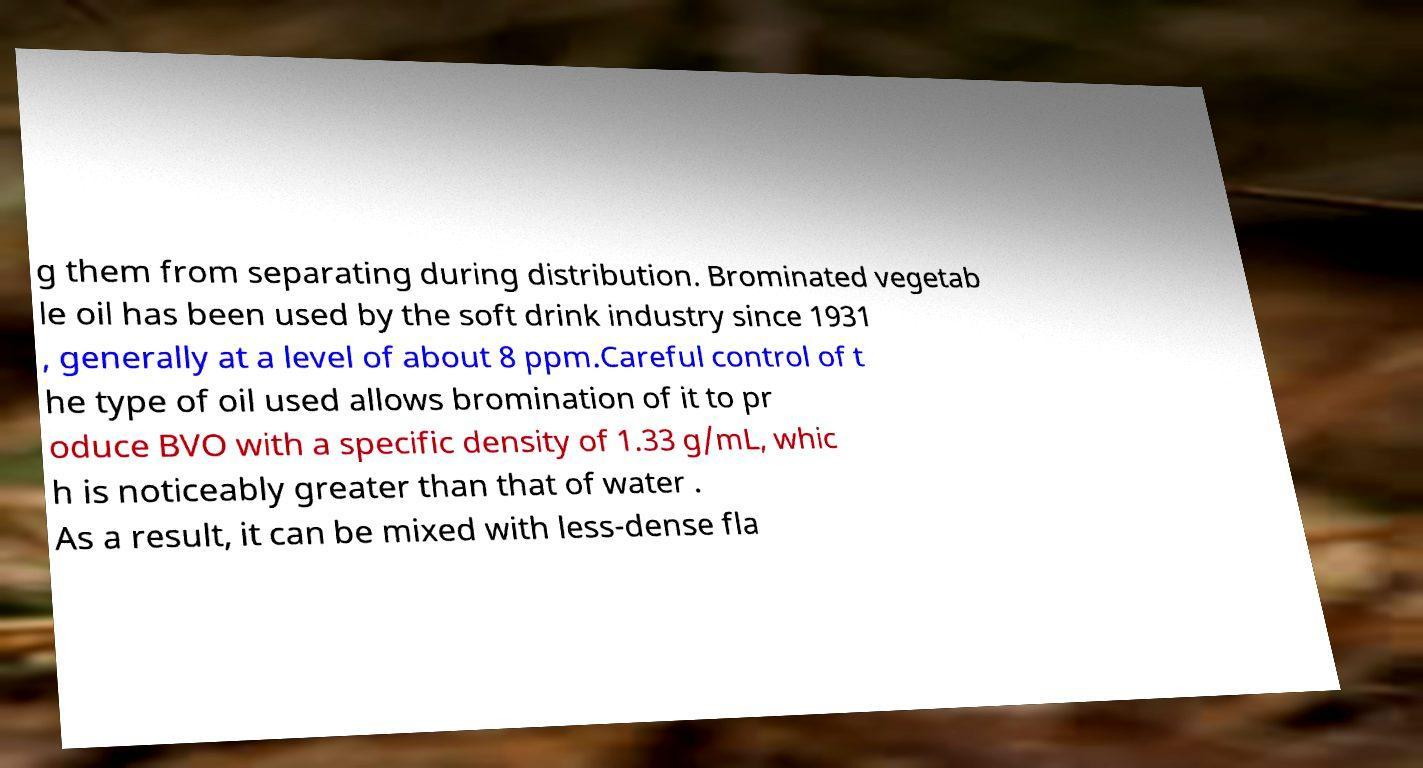Could you extract and type out the text from this image? g them from separating during distribution. Brominated vegetab le oil has been used by the soft drink industry since 1931 , generally at a level of about 8 ppm.Careful control of t he type of oil used allows bromination of it to pr oduce BVO with a specific density of 1.33 g/mL, whic h is noticeably greater than that of water . As a result, it can be mixed with less-dense fla 